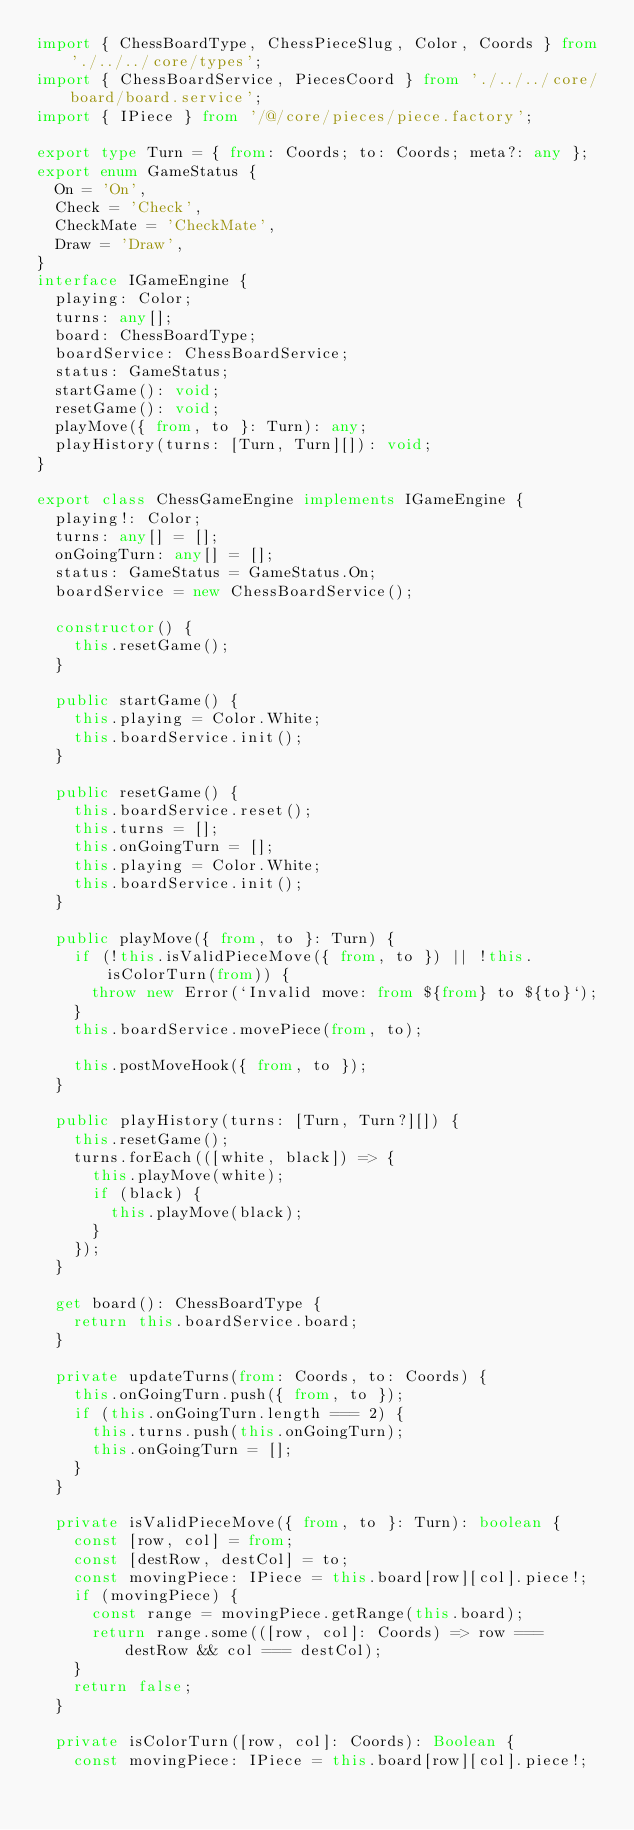<code> <loc_0><loc_0><loc_500><loc_500><_TypeScript_>import { ChessBoardType, ChessPieceSlug, Color, Coords } from './../../core/types';
import { ChessBoardService, PiecesCoord } from './../../core/board/board.service';
import { IPiece } from '/@/core/pieces/piece.factory';

export type Turn = { from: Coords; to: Coords; meta?: any };
export enum GameStatus {
  On = 'On',
  Check = 'Check',
  CheckMate = 'CheckMate',
  Draw = 'Draw',
}
interface IGameEngine {
  playing: Color;
  turns: any[];
  board: ChessBoardType;
  boardService: ChessBoardService;
  status: GameStatus;
  startGame(): void;
  resetGame(): void;
  playMove({ from, to }: Turn): any;
  playHistory(turns: [Turn, Turn][]): void;
}

export class ChessGameEngine implements IGameEngine {
  playing!: Color;
  turns: any[] = [];
  onGoingTurn: any[] = [];
  status: GameStatus = GameStatus.On;
  boardService = new ChessBoardService();

  constructor() {
    this.resetGame();
  }

  public startGame() {
    this.playing = Color.White;
    this.boardService.init();
  }

  public resetGame() {
    this.boardService.reset();
    this.turns = [];
    this.onGoingTurn = [];
    this.playing = Color.White;
    this.boardService.init();
  }

  public playMove({ from, to }: Turn) {
    if (!this.isValidPieceMove({ from, to }) || !this.isColorTurn(from)) {
      throw new Error(`Invalid move: from ${from} to ${to}`);
    }
    this.boardService.movePiece(from, to);

    this.postMoveHook({ from, to });
  }

  public playHistory(turns: [Turn, Turn?][]) {
    this.resetGame();
    turns.forEach(([white, black]) => {
      this.playMove(white);
      if (black) {
        this.playMove(black);
      }
    });
  }

  get board(): ChessBoardType {
    return this.boardService.board;
  }

  private updateTurns(from: Coords, to: Coords) {
    this.onGoingTurn.push({ from, to });
    if (this.onGoingTurn.length === 2) {
      this.turns.push(this.onGoingTurn);
      this.onGoingTurn = [];
    }
  }

  private isValidPieceMove({ from, to }: Turn): boolean {
    const [row, col] = from;
    const [destRow, destCol] = to;
    const movingPiece: IPiece = this.board[row][col].piece!;
    if (movingPiece) {
      const range = movingPiece.getRange(this.board);
      return range.some(([row, col]: Coords) => row === destRow && col === destCol);
    }
    return false;
  }

  private isColorTurn([row, col]: Coords): Boolean {
    const movingPiece: IPiece = this.board[row][col].piece!;</code> 